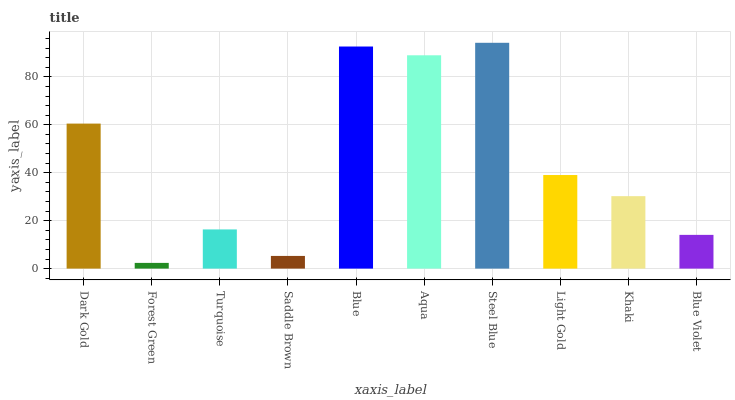Is Forest Green the minimum?
Answer yes or no. Yes. Is Steel Blue the maximum?
Answer yes or no. Yes. Is Turquoise the minimum?
Answer yes or no. No. Is Turquoise the maximum?
Answer yes or no. No. Is Turquoise greater than Forest Green?
Answer yes or no. Yes. Is Forest Green less than Turquoise?
Answer yes or no. Yes. Is Forest Green greater than Turquoise?
Answer yes or no. No. Is Turquoise less than Forest Green?
Answer yes or no. No. Is Light Gold the high median?
Answer yes or no. Yes. Is Khaki the low median?
Answer yes or no. Yes. Is Steel Blue the high median?
Answer yes or no. No. Is Turquoise the low median?
Answer yes or no. No. 